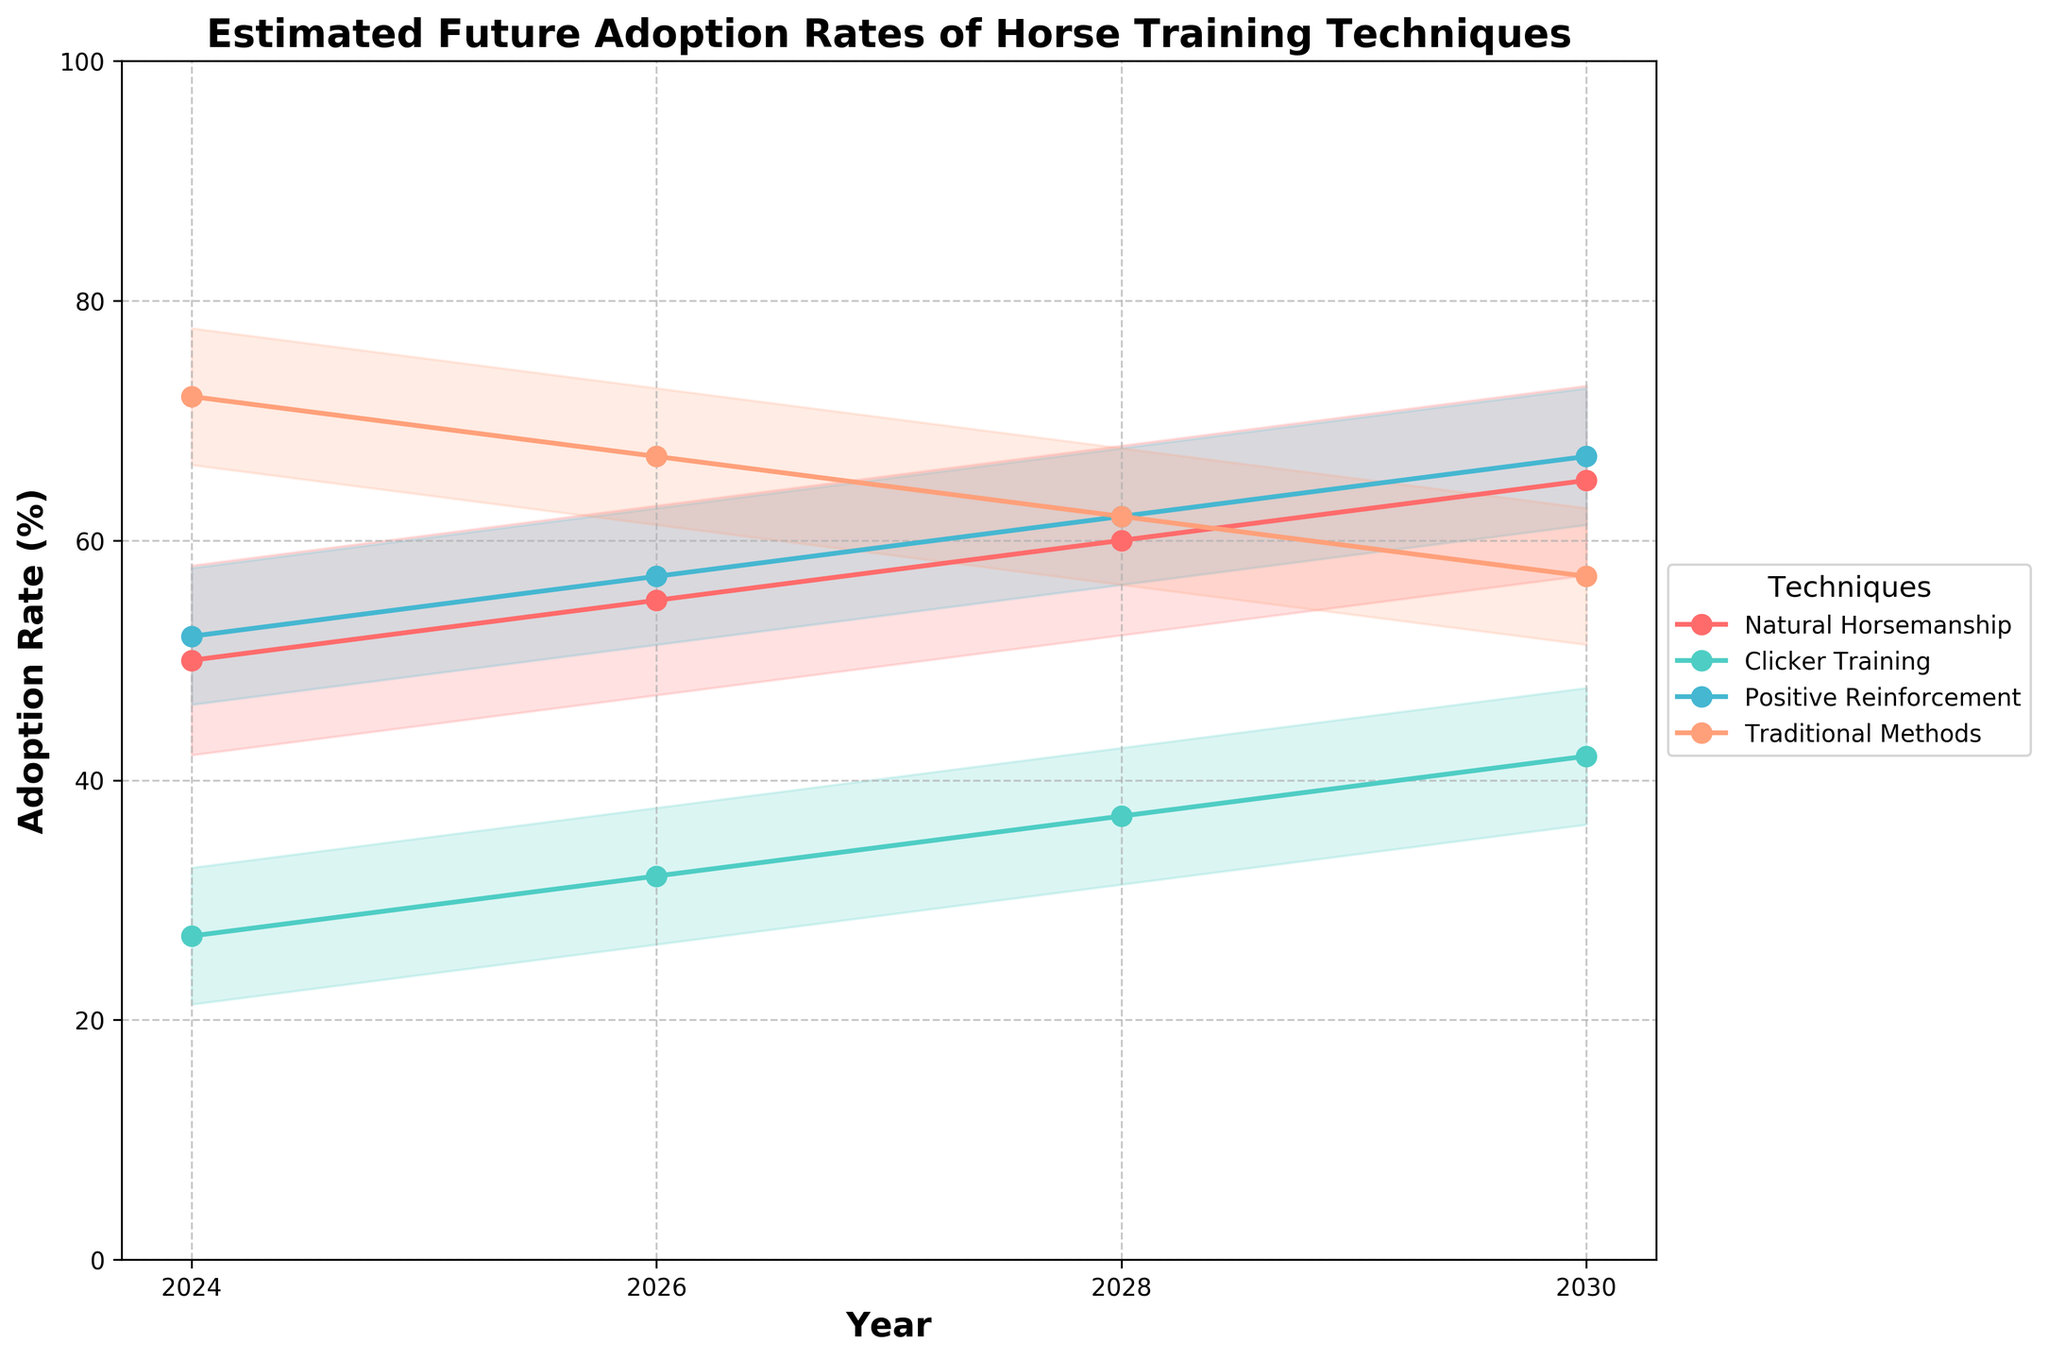What is the title of the figure? The title of the figure is typically found at the top of the chart and summarizes the visualized data. Here, the title is prominently displayed.
Answer: Estimated Future Adoption Rates of Horse Training Techniques How many years are displayed on the x-axis? The x-axis shows the points in time for which data is provided. By counting the tick marks or year labels, we see the number.
Answer: 4 Which horse training technique has the highest estimated adoption rate in 2024 for Dressage? Looking at the estimated adoption rates in the 2024 column for Dressage across different techniques, find the highest value.
Answer: Traditional Methods What is the general trend for Natural Horsemanship techniques from 2024 to 2030? Identify the values for Natural Horsemanship for all years and observe how they change over time.
Answer: Increasing What is the average adoption rate for Clicker Training across all disciplines in 2028? For Clicker Training in 2028, sum all the adoption rates for each discipline and divide by the number of disciplines.
Answer: 37 Which training technique exhibits the largest variance in adoption rates in 2026? Calculate the standard deviation of adoption rates across the disciplines for each technique in 2026 and identify the largest value.
Answer: Positive Reinforcement Between 2026 and 2030, which technique shows the most significant decrease in adoption rate within any single discipline? For each technique, compare the values between 2026 and 2030 in each discipline and find the maximum negative difference.
Answer: Traditional Methods (Eventing) How does the adoption rate of Positive Reinforcement in Show Jumping compare to Clicker Training in Eventing by 2030? Look at the adoption rates of Positive Reinforcement in Show Jumping and Clicker Training in Eventing for the year 2030 and compare them.
Answer: Higher What is the spread (difference between maximum and minimum) of adoption rates for Traditional Methods among all disciplines in 2024? Identify the highest and lowest adoption rates for Traditional Methods across all disciplines in 2024 and subtract the minimum from the maximum.
Answer: 15 Which technique is expected to have a more consistent adoption rate across all disciplines by 2030? Find the technique with the smallest fill (range of standard deviation) around the mean line among all disciplines by the year 2030.
Answer: Positive Reinforcement 